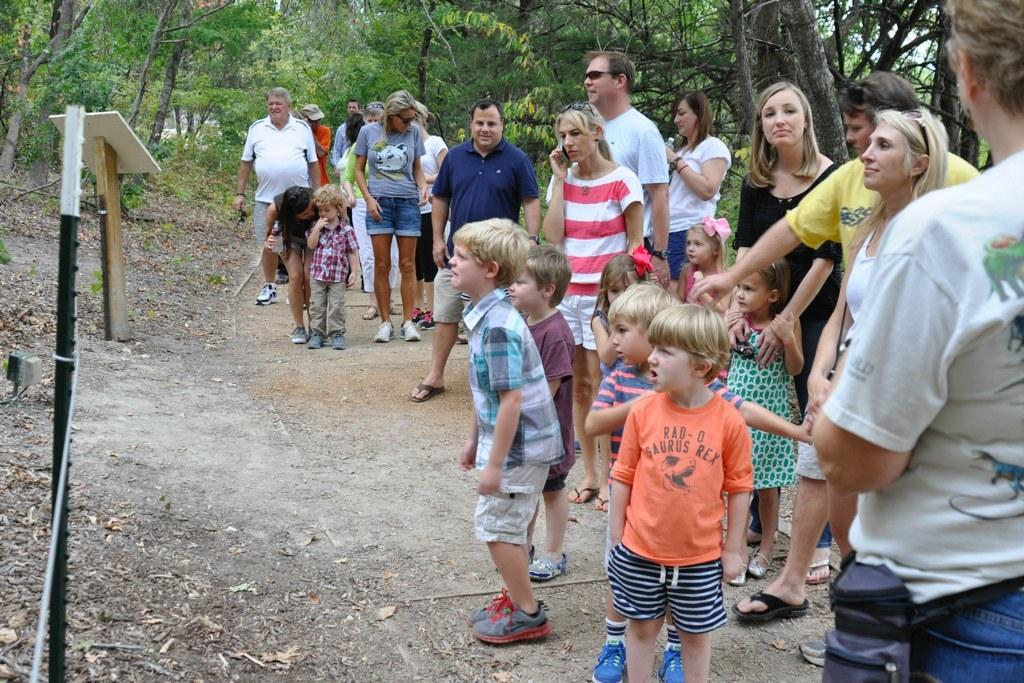What type of natural elements can be seen in the image? There are trees in the image. What structure is present in the image? There is a podium in the image. What man-made object can be seen in the image? There is a pole in the image. What additional object is present in the image? There is a rope in the image. Can you describe the general contents of the image? There are objects in the image. Where are the people located in the image? There are people on the right side of the image. What is the woman holding in the image? A woman is holding a water bottle. What type of lead is being used to connect the calculator to the system in the image? There is no calculator or system present in the image, and therefore no such connection can be observed. 